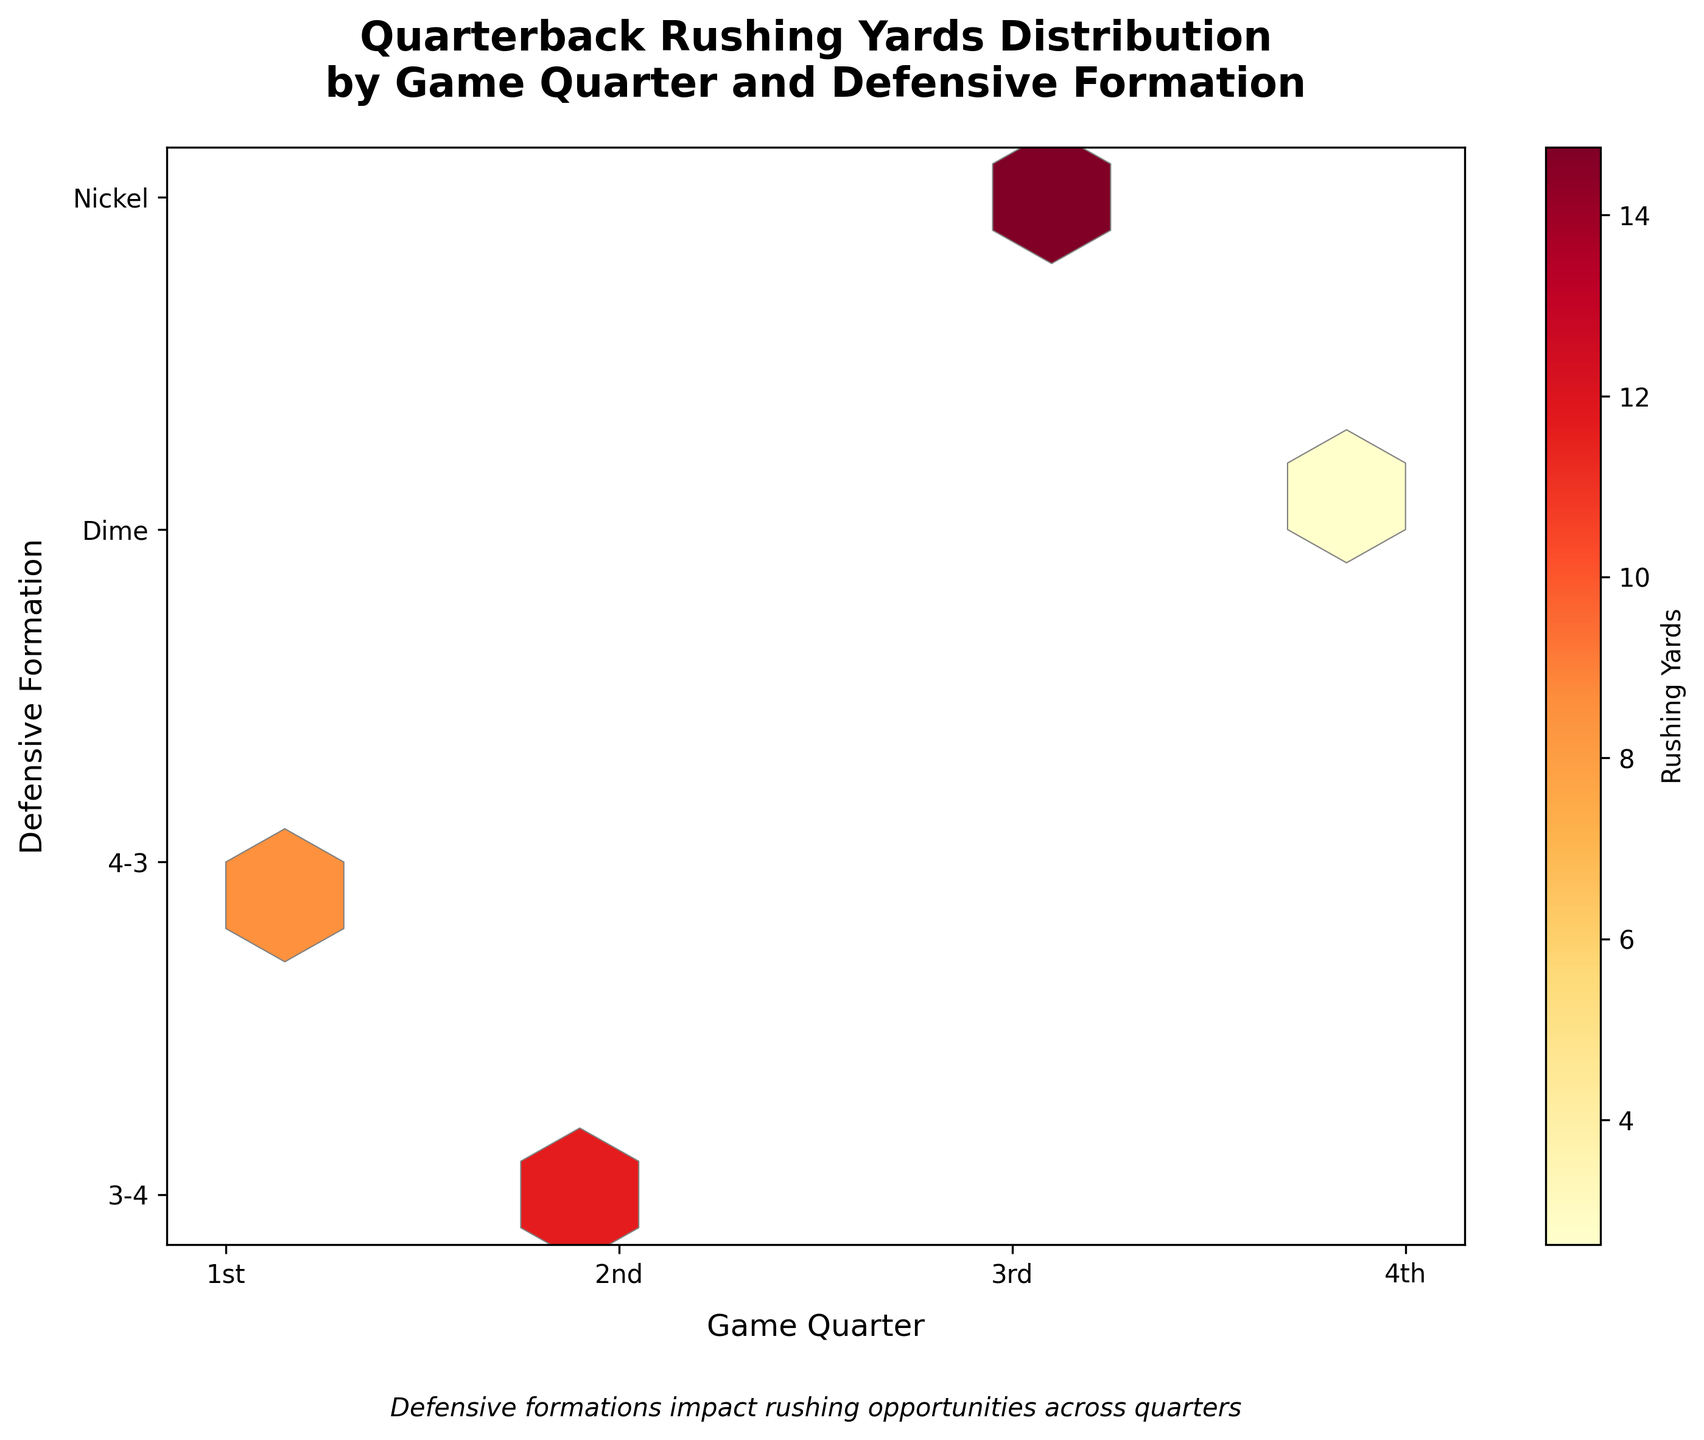What is the title of the figure? The title is usually placed at the top of the figure, providing a clear summary of what the plot represents. In this case, it's mentioned in the code.
Answer: Quarterback Rushing Yards Distribution by Game Quarter and Defensive Formation What are the axis labels and their units? Axis labels are found along the horizontal (x-axis) and vertical (y-axis) lines of the plot. They provide information on what each axis represents and the units used. Here, it's explicitly stated in the code.
Answer: Game Quarter (x-axis), Defensive Formation (y-axis) Which game quarter shows the highest rushing yards against a 3-4 defensive formation? By analyzing the hexbin plot's color intensity in different areas, you can identify where the highest rushing yards are located. More intense colors represent higher rushing yards. Compare the '3-4' row across all four quarters.
Answer: 2nd quarter In which game quarter are the rushing yards against Nickel formation the highest? Look at the hexbin colors in the row corresponding to the 'Nickel' formation. The most intense color indicates the highest rushing yards.
Answer: 3rd quarter Which defensive formation is least effective in stopping rushing yards during the 4th quarter? To determine this, identify the hexbin with the lightest color or smallest color intensity within the 4th quarter column, which indicates lower rushing yards.
Answer: Nickel Which game quarter has the most balanced rushing yards across different defensive formations? For a balanced rushing yard distribution, the hexbin colors should appear uniformly similar across the different defensive formations within a specific quarter. Compare the color patterns across the columns of each quarter.
Answer: 4th quarter How does the rushing yard distribution vary between 3-4 and Dime formations in the 2nd quarter? Compare the hexbin colors for the '3-4' and 'Dime' rows within the 2nd quarter column. The color intensity differences reveal the variance in rushing yards.
Answer: More rushing yards against 3-4 What is the overall trend of rushing yards from the 1st to the 4th quarter? Observe the color intensity across the hexbin bins from the 1st to the 4th quarter. A trend can be inferred by either increasing, decreasing, or consistent color intensities.
Answer: Generally decreasing Which game quarter and defensive formation combination shows the least rushing yards? This would be found by locating the least intense or lightest colored hexbin.
Answer: Dime formation in the 4th quarter 